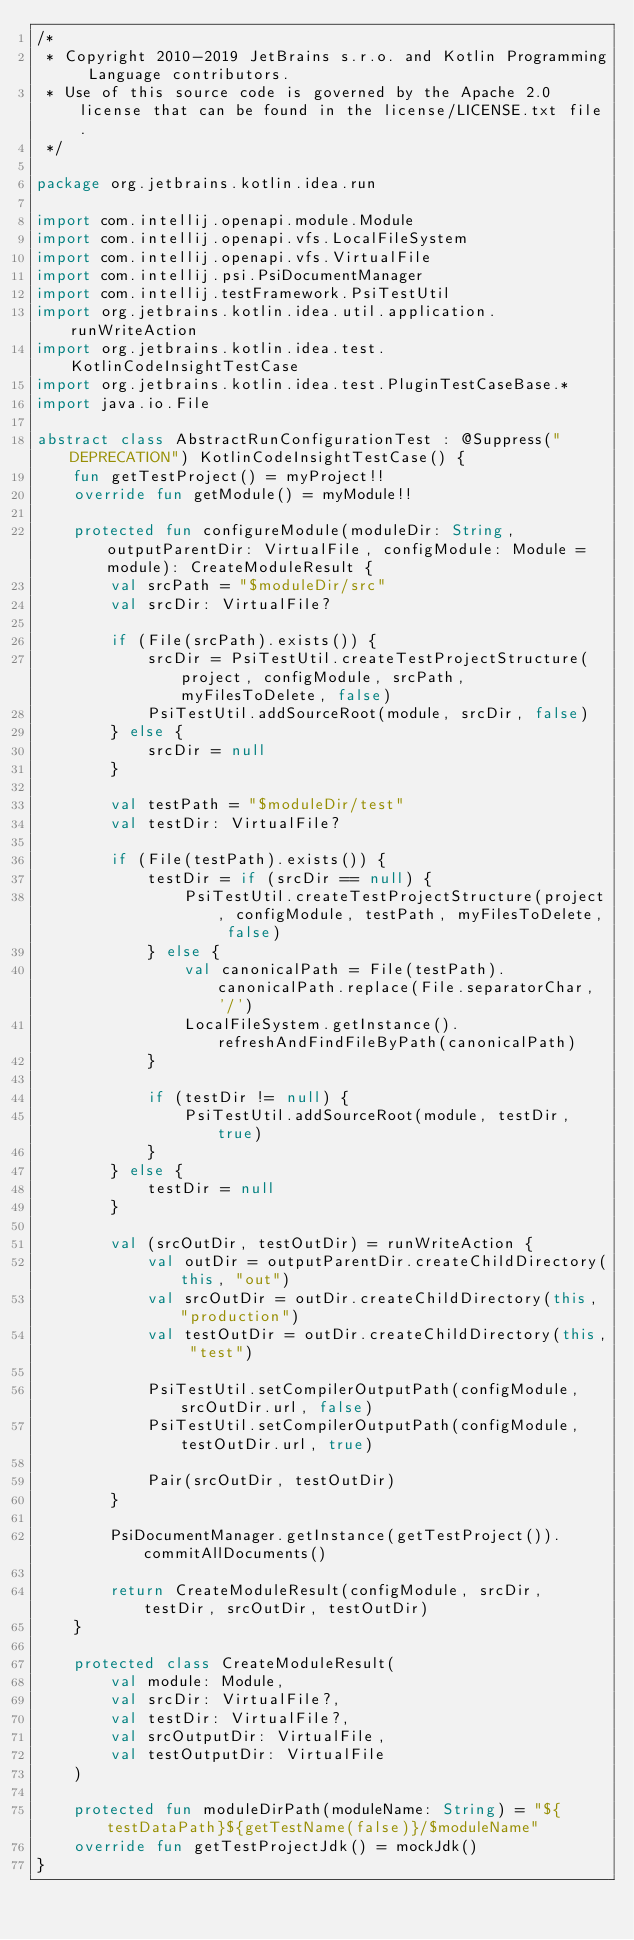Convert code to text. <code><loc_0><loc_0><loc_500><loc_500><_Kotlin_>/*
 * Copyright 2010-2019 JetBrains s.r.o. and Kotlin Programming Language contributors.
 * Use of this source code is governed by the Apache 2.0 license that can be found in the license/LICENSE.txt file.
 */

package org.jetbrains.kotlin.idea.run

import com.intellij.openapi.module.Module
import com.intellij.openapi.vfs.LocalFileSystem
import com.intellij.openapi.vfs.VirtualFile
import com.intellij.psi.PsiDocumentManager
import com.intellij.testFramework.PsiTestUtil
import org.jetbrains.kotlin.idea.util.application.runWriteAction
import org.jetbrains.kotlin.idea.test.KotlinCodeInsightTestCase
import org.jetbrains.kotlin.idea.test.PluginTestCaseBase.*
import java.io.File

abstract class AbstractRunConfigurationTest : @Suppress("DEPRECATION") KotlinCodeInsightTestCase() {
    fun getTestProject() = myProject!!
    override fun getModule() = myModule!!

    protected fun configureModule(moduleDir: String, outputParentDir: VirtualFile, configModule: Module = module): CreateModuleResult {
        val srcPath = "$moduleDir/src"
        val srcDir: VirtualFile?

        if (File(srcPath).exists()) {
            srcDir = PsiTestUtil.createTestProjectStructure(project, configModule, srcPath, myFilesToDelete, false)
            PsiTestUtil.addSourceRoot(module, srcDir, false)
        } else {
            srcDir = null
        }

        val testPath = "$moduleDir/test"
        val testDir: VirtualFile?

        if (File(testPath).exists()) {
            testDir = if (srcDir == null) {
                PsiTestUtil.createTestProjectStructure(project, configModule, testPath, myFilesToDelete, false)
            } else {
                val canonicalPath = File(testPath).canonicalPath.replace(File.separatorChar, '/')
                LocalFileSystem.getInstance().refreshAndFindFileByPath(canonicalPath)
            }

            if (testDir != null) {
                PsiTestUtil.addSourceRoot(module, testDir, true)
            }
        } else {
            testDir = null
        }

        val (srcOutDir, testOutDir) = runWriteAction {
            val outDir = outputParentDir.createChildDirectory(this, "out")
            val srcOutDir = outDir.createChildDirectory(this, "production")
            val testOutDir = outDir.createChildDirectory(this, "test")

            PsiTestUtil.setCompilerOutputPath(configModule, srcOutDir.url, false)
            PsiTestUtil.setCompilerOutputPath(configModule, testOutDir.url, true)

            Pair(srcOutDir, testOutDir)
        }

        PsiDocumentManager.getInstance(getTestProject()).commitAllDocuments()

        return CreateModuleResult(configModule, srcDir, testDir, srcOutDir, testOutDir)
    }

    protected class CreateModuleResult(
        val module: Module,
        val srcDir: VirtualFile?,
        val testDir: VirtualFile?,
        val srcOutputDir: VirtualFile,
        val testOutputDir: VirtualFile
    )

    protected fun moduleDirPath(moduleName: String) = "${testDataPath}${getTestName(false)}/$moduleName"
    override fun getTestProjectJdk() = mockJdk()
}</code> 